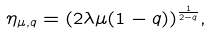Convert formula to latex. <formula><loc_0><loc_0><loc_500><loc_500>\eta _ { \mu , q } = ( 2 \lambda \mu ( 1 - q ) ) ^ { \frac { 1 } { 2 - q } } ,</formula> 